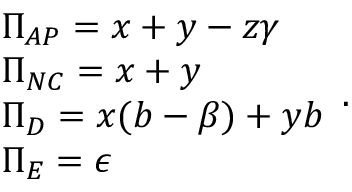<formula> <loc_0><loc_0><loc_500><loc_500>\begin{array} { l } { \Pi _ { A P } = x + y - z \gamma } \\ { \Pi _ { N C } = x + y } \\ { \Pi _ { D } = x ( b - \beta ) + y b } \\ { \Pi _ { E } = \epsilon } \end{array} .</formula> 